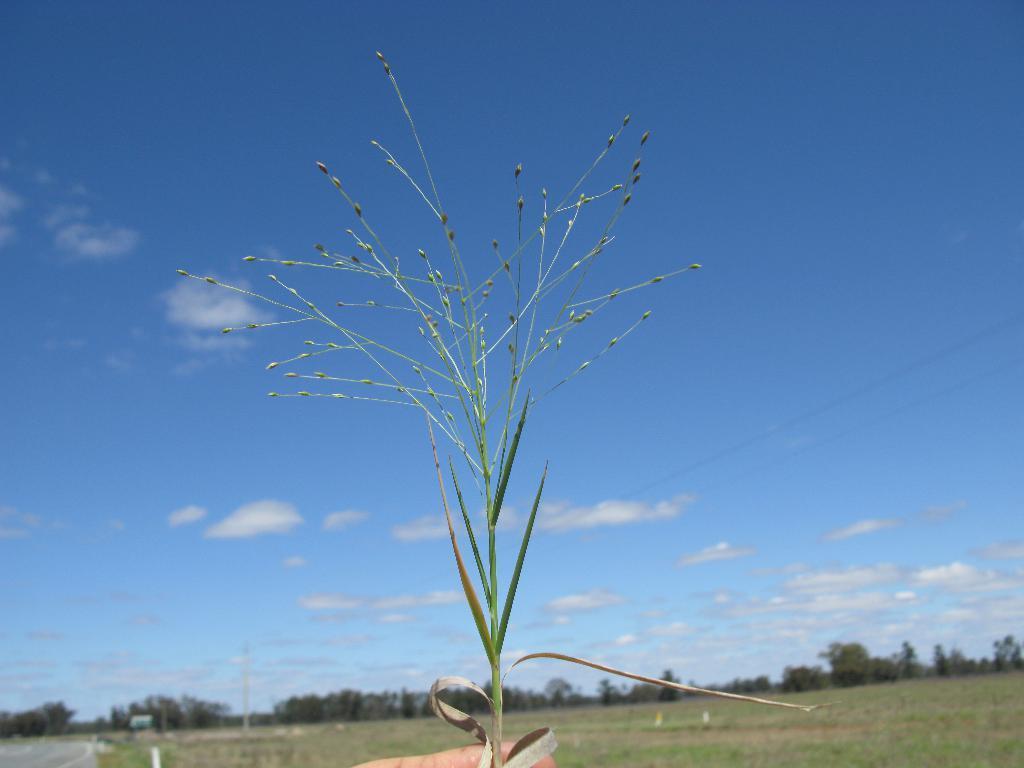In one or two sentences, can you explain what this image depicts? In this image we can see sky with clouds, trees, ground and a plant. 